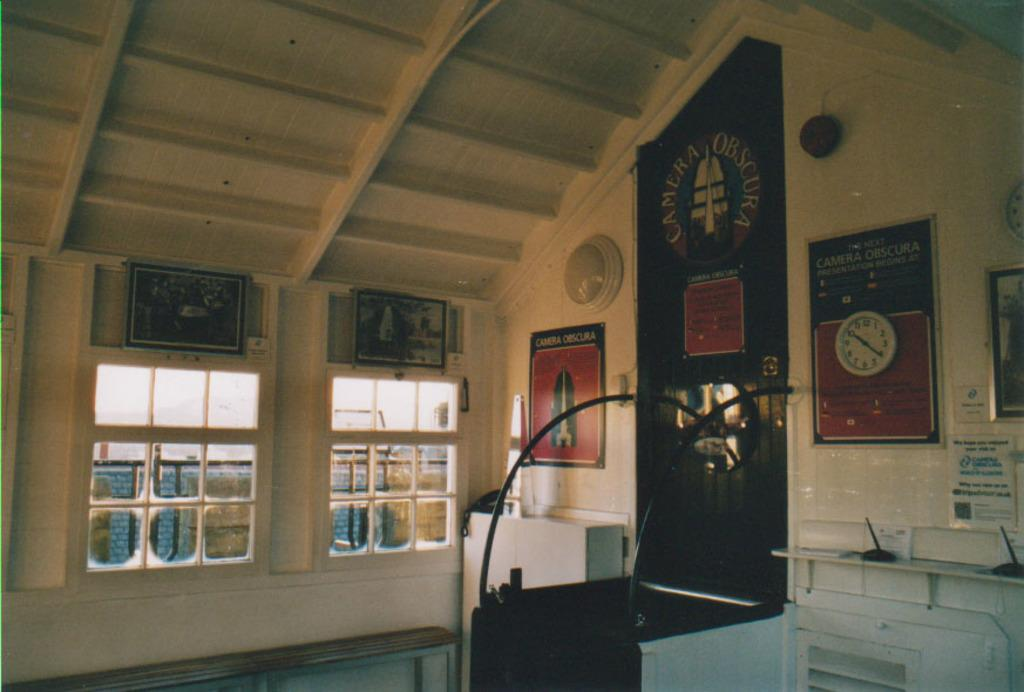What can be seen attached to the wall in the room? There are frames attached to the wall in the room. How many windows are present in the room? There are two windows in the room. What object is located beside the windows? There is a telephone beside the windows. What can be seen in the background of the room? There is a wall visible in the background. What type of plot is being discussed in the room? There is no indication of a plot being discussed in the room; the image only shows frames on the wall, two windows, a telephone, and a wall in the background. 